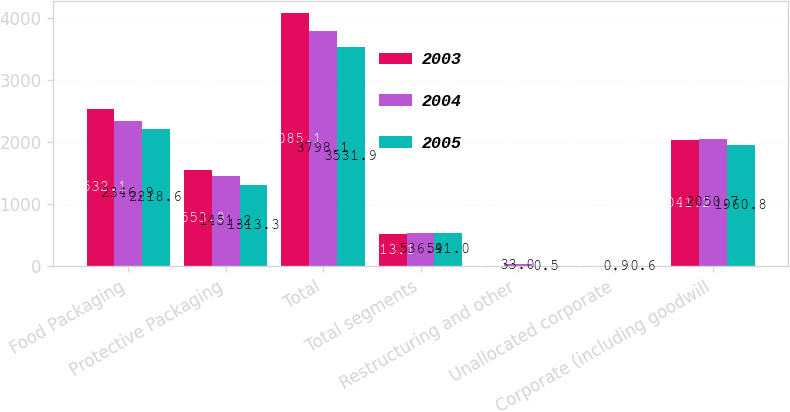<chart> <loc_0><loc_0><loc_500><loc_500><stacked_bar_chart><ecel><fcel>Food Packaging<fcel>Protective Packaging<fcel>Total<fcel>Total segments<fcel>Restructuring and other<fcel>Unallocated corporate<fcel>Corporate (including goodwill<nl><fcel>2003<fcel>2532.1<fcel>1553<fcel>4085.1<fcel>513.1<fcel>1.7<fcel>1<fcel>2041.2<nl><fcel>2004<fcel>2346.9<fcel>1451.2<fcel>3798.1<fcel>536.9<fcel>33<fcel>0.9<fcel>2050.7<nl><fcel>2005<fcel>2218.6<fcel>1313.3<fcel>3531.9<fcel>541<fcel>0.5<fcel>0.6<fcel>1960.8<nl></chart> 